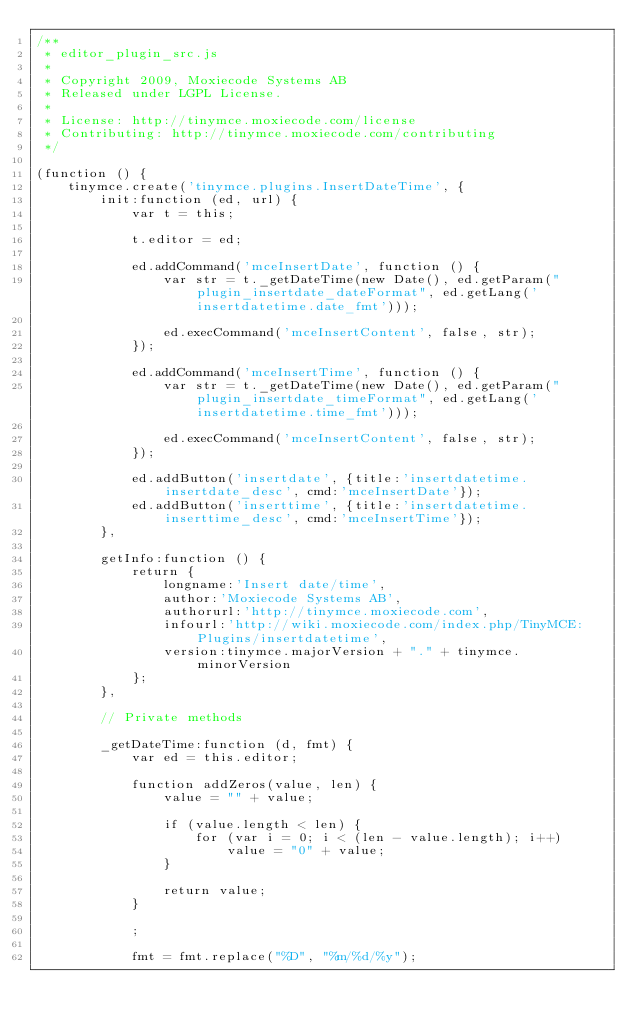Convert code to text. <code><loc_0><loc_0><loc_500><loc_500><_JavaScript_>/**
 * editor_plugin_src.js
 *
 * Copyright 2009, Moxiecode Systems AB
 * Released under LGPL License.
 *
 * License: http://tinymce.moxiecode.com/license
 * Contributing: http://tinymce.moxiecode.com/contributing
 */

(function () {
    tinymce.create('tinymce.plugins.InsertDateTime', {
        init:function (ed, url) {
            var t = this;

            t.editor = ed;

            ed.addCommand('mceInsertDate', function () {
                var str = t._getDateTime(new Date(), ed.getParam("plugin_insertdate_dateFormat", ed.getLang('insertdatetime.date_fmt')));

                ed.execCommand('mceInsertContent', false, str);
            });

            ed.addCommand('mceInsertTime', function () {
                var str = t._getDateTime(new Date(), ed.getParam("plugin_insertdate_timeFormat", ed.getLang('insertdatetime.time_fmt')));

                ed.execCommand('mceInsertContent', false, str);
            });

            ed.addButton('insertdate', {title:'insertdatetime.insertdate_desc', cmd:'mceInsertDate'});
            ed.addButton('inserttime', {title:'insertdatetime.inserttime_desc', cmd:'mceInsertTime'});
        },

        getInfo:function () {
            return {
                longname:'Insert date/time',
                author:'Moxiecode Systems AB',
                authorurl:'http://tinymce.moxiecode.com',
                infourl:'http://wiki.moxiecode.com/index.php/TinyMCE:Plugins/insertdatetime',
                version:tinymce.majorVersion + "." + tinymce.minorVersion
            };
        },

        // Private methods

        _getDateTime:function (d, fmt) {
            var ed = this.editor;

            function addZeros(value, len) {
                value = "" + value;

                if (value.length < len) {
                    for (var i = 0; i < (len - value.length); i++)
                        value = "0" + value;
                }

                return value;
            }

            ;

            fmt = fmt.replace("%D", "%m/%d/%y");</code> 